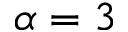<formula> <loc_0><loc_0><loc_500><loc_500>\alpha = 3</formula> 